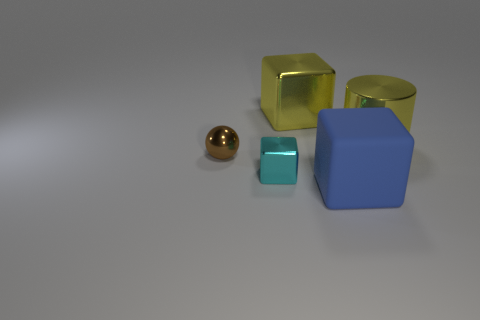Are there any objects that are similar in color but different in shape? Yes, there are two objects that are similar in a golden color but different in shape; one is a sphere and the other is a cube. 